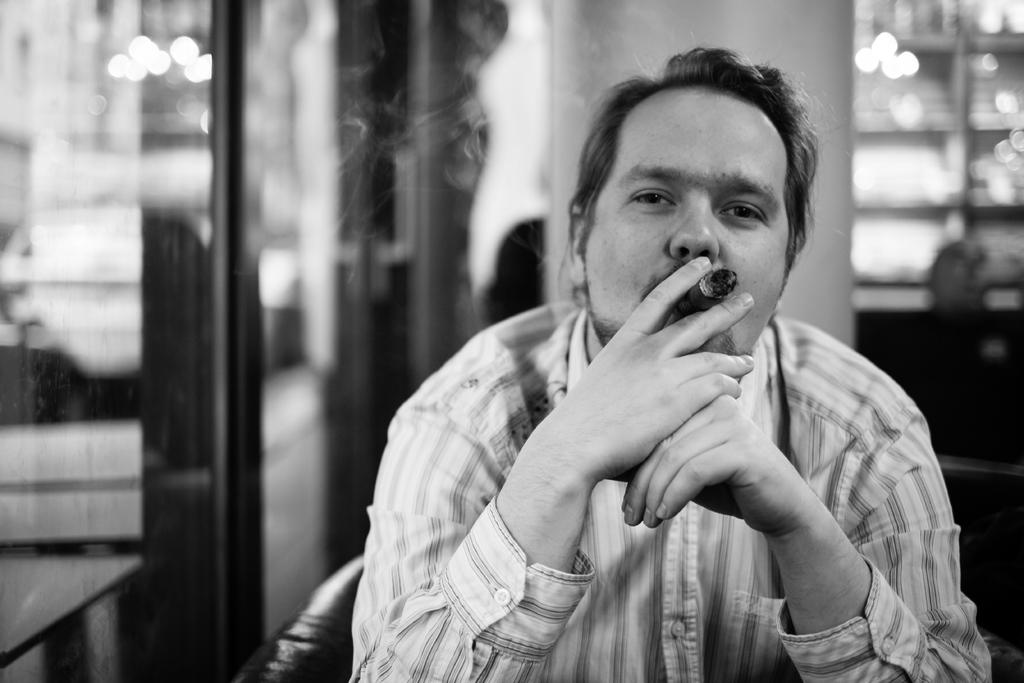What is the person in the image doing? The person is sitting on a chair in the image. What is the person holding in the image? The person is holding a cigarette. What can be seen in the background of the image? There is a wall, a glass, and a table in the background of the image. Are there any other objects visible in the background? Yes, there are a few other objects in the background of the image. What type of shade is covering the station in the image? There is no shade or station present in the image. 